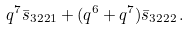Convert formula to latex. <formula><loc_0><loc_0><loc_500><loc_500>q ^ { 7 } \bar { s } _ { 3 2 2 1 } + ( q ^ { 6 } + q ^ { 7 } ) \bar { s } _ { 3 2 2 2 } \, .</formula> 